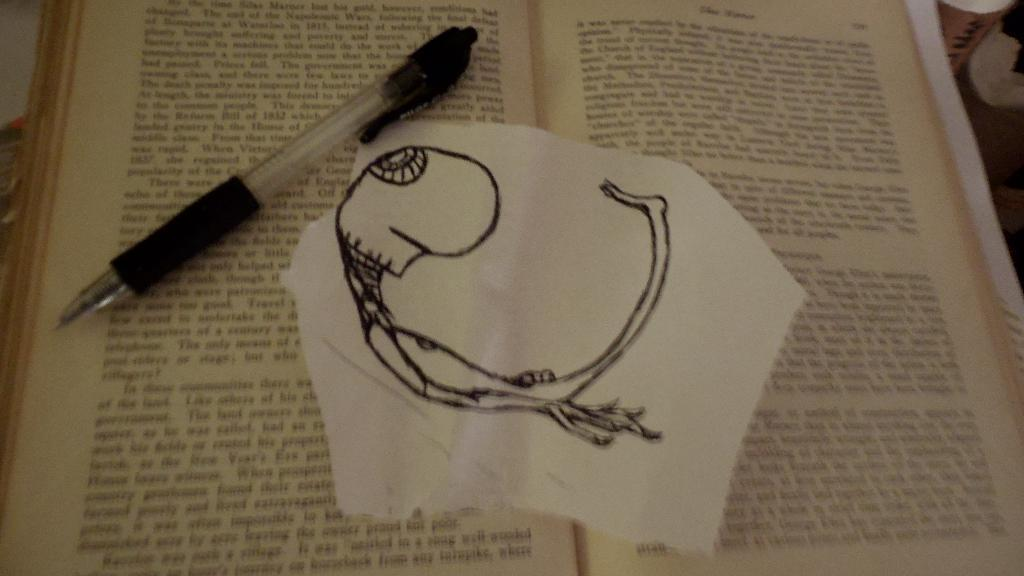What stationery item is visible in the image? There is a pen in the image. What is the pen placed on in the image? The pen and paper are on a book. What type of surface is the pen and paper resting on? The pen and paper are resting on a book. What type of wilderness can be seen in the background of the image? There is no wilderness visible in the image; it only shows a pen, paper, and a book. How many eyes are visible in the image? There are no eyes visible in the image; it only shows a pen, paper, and a book. 